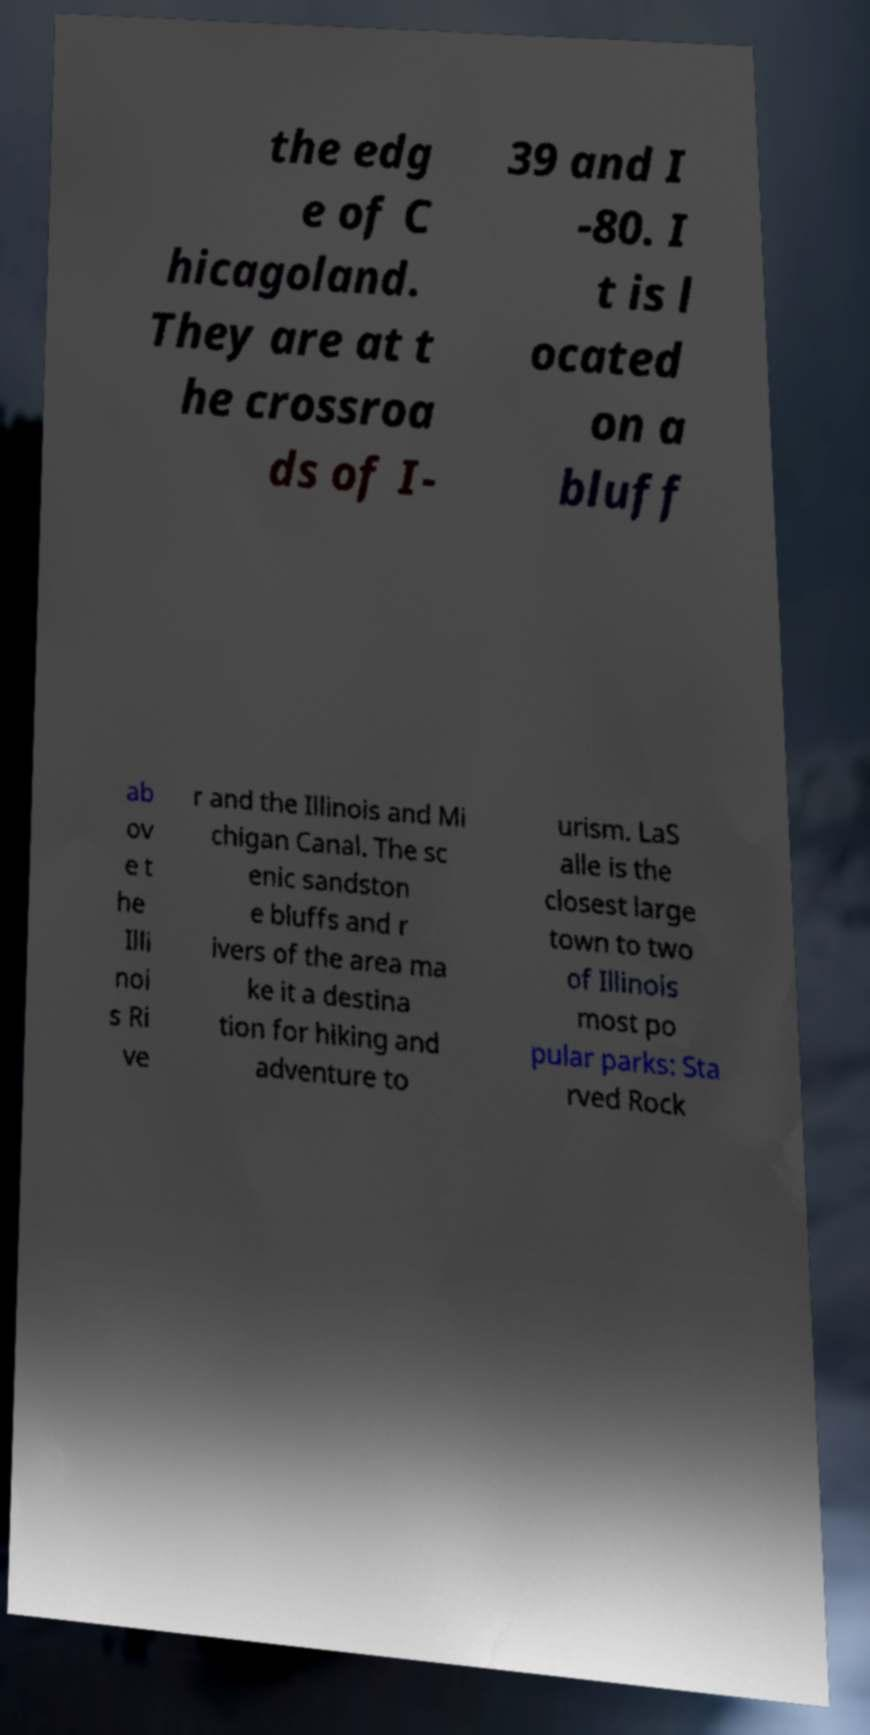For documentation purposes, I need the text within this image transcribed. Could you provide that? the edg e of C hicagoland. They are at t he crossroa ds of I- 39 and I -80. I t is l ocated on a bluff ab ov e t he Illi noi s Ri ve r and the Illinois and Mi chigan Canal. The sc enic sandston e bluffs and r ivers of the area ma ke it a destina tion for hiking and adventure to urism. LaS alle is the closest large town to two of Illinois most po pular parks: Sta rved Rock 